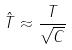<formula> <loc_0><loc_0><loc_500><loc_500>\hat { T } \approx \frac { T } { \sqrt { C } }</formula> 